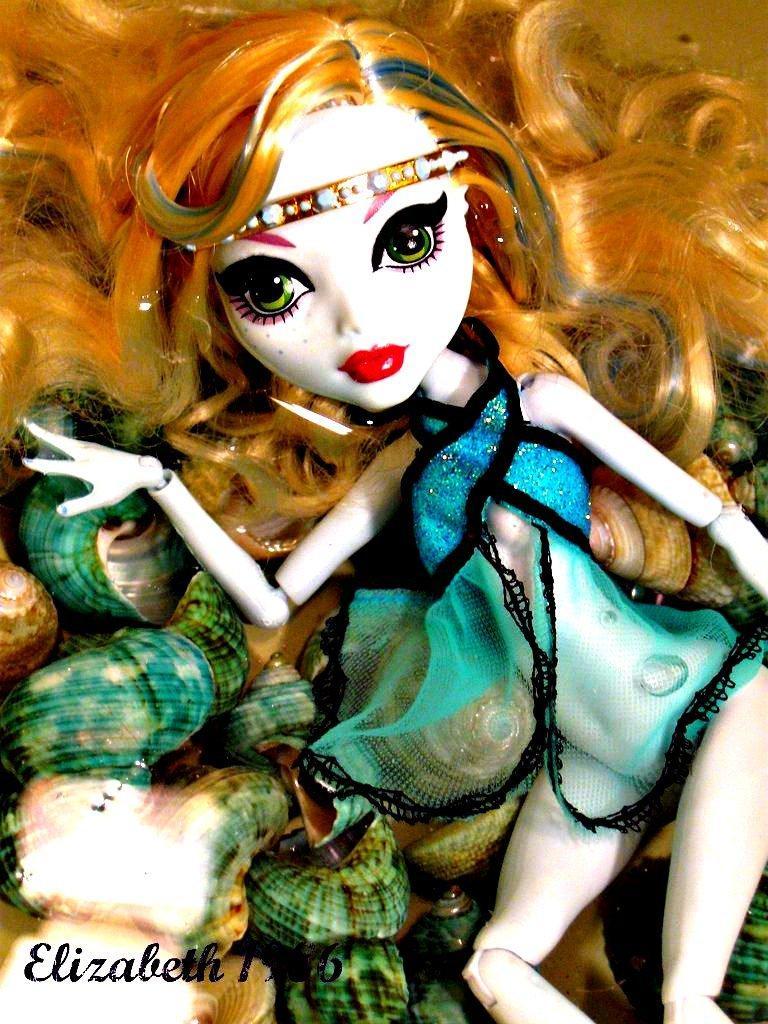In one or two sentences, can you explain what this image depicts? In this image it seems like an animated image in the middle. In the background there are few objects which looks like shells. 